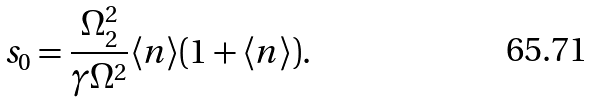<formula> <loc_0><loc_0><loc_500><loc_500>s _ { 0 } = \frac { \Omega _ { 2 } ^ { 2 } } { \gamma \Omega ^ { 2 } } \langle n \rangle ( 1 + \langle n \rangle ) .</formula> 